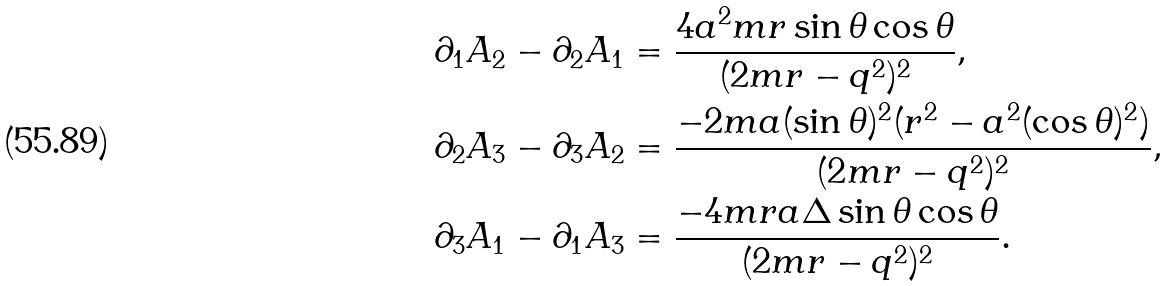<formula> <loc_0><loc_0><loc_500><loc_500>& \partial _ { 1 } A _ { 2 } - \partial _ { 2 } A _ { 1 } = \frac { 4 a ^ { 2 } m r \sin \theta \cos \theta } { ( 2 m r - q ^ { 2 } ) ^ { 2 } } , \\ & \partial _ { 2 } A _ { 3 } - \partial _ { 3 } A _ { 2 } = \frac { - 2 m a ( \sin \theta ) ^ { 2 } ( r ^ { 2 } - a ^ { 2 } ( \cos \theta ) ^ { 2 } ) } { ( 2 m r - q ^ { 2 } ) ^ { 2 } } , \\ & \partial _ { 3 } A _ { 1 } - \partial _ { 1 } A _ { 3 } = \frac { - 4 m r a \Delta \sin \theta \cos \theta } { ( 2 m r - q ^ { 2 } ) ^ { 2 } } .</formula> 